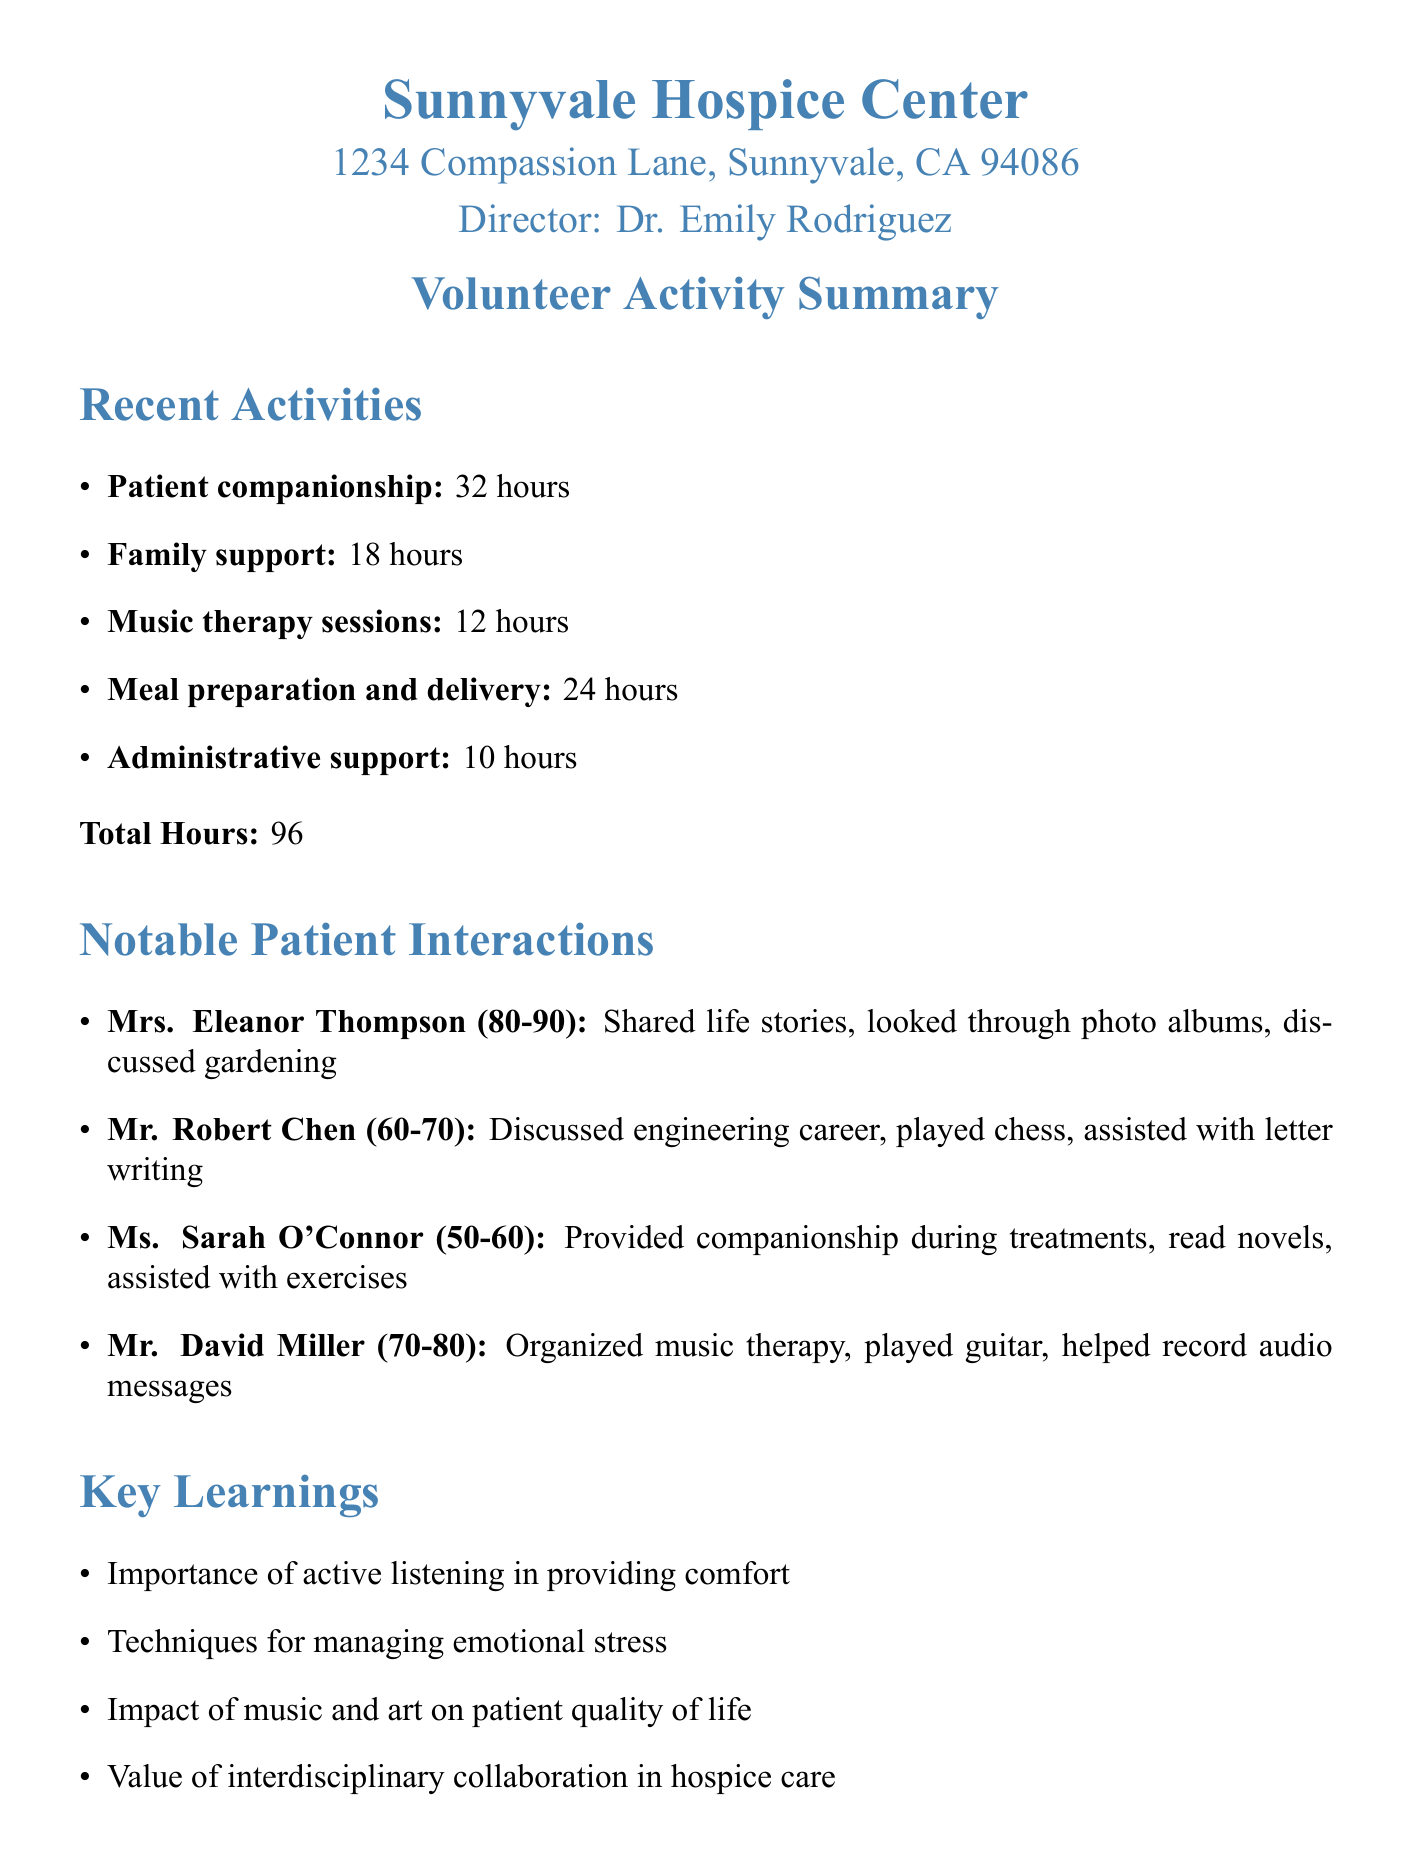What is the total number of hours worked by volunteers? The total number of hours worked is explicitly stated in the document as the sum of all activities.
Answer: 96 What activity involved providing companionship to terminally ill patients? The document specifies the activity that focused on patient companionship, detailing the hours involved.
Answer: Patient companionship Who is the director of the Sunnyvale Hospice Center? The document provides the name of the director under hospice information.
Answer: Dr. Emily Rodriguez How many hours were dedicated to music therapy sessions? The hours for each activity, including music therapy sessions, are mentioned in the recent activities section.
Answer: 12 Which patient was engaged in discussions about their career as an engineer? The document identifies the patient's name and the context of their interaction in the notable patient interactions section.
Answer: Mr. Robert Chen What is a key learning from the volunteer activities? The document lists several key learnings, indicating their significance in providing care.
Answer: Importance of active listening in providing comfort What upcoming initiative involves collaboration with local animal shelters? The document briefly describes the upcoming initiatives, including one related to animal shelters.
Answer: Implementation of a new pet therapy program How many hours were spent on family support activities? The hours for each category of activities are outlined clearly, including family support.
Answer: 18 